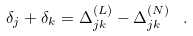Convert formula to latex. <formula><loc_0><loc_0><loc_500><loc_500>\delta _ { j } + \delta _ { k } = \Delta ^ { ( L ) } _ { j k } - \Delta ^ { ( N ) } _ { j k } \, \ .</formula> 